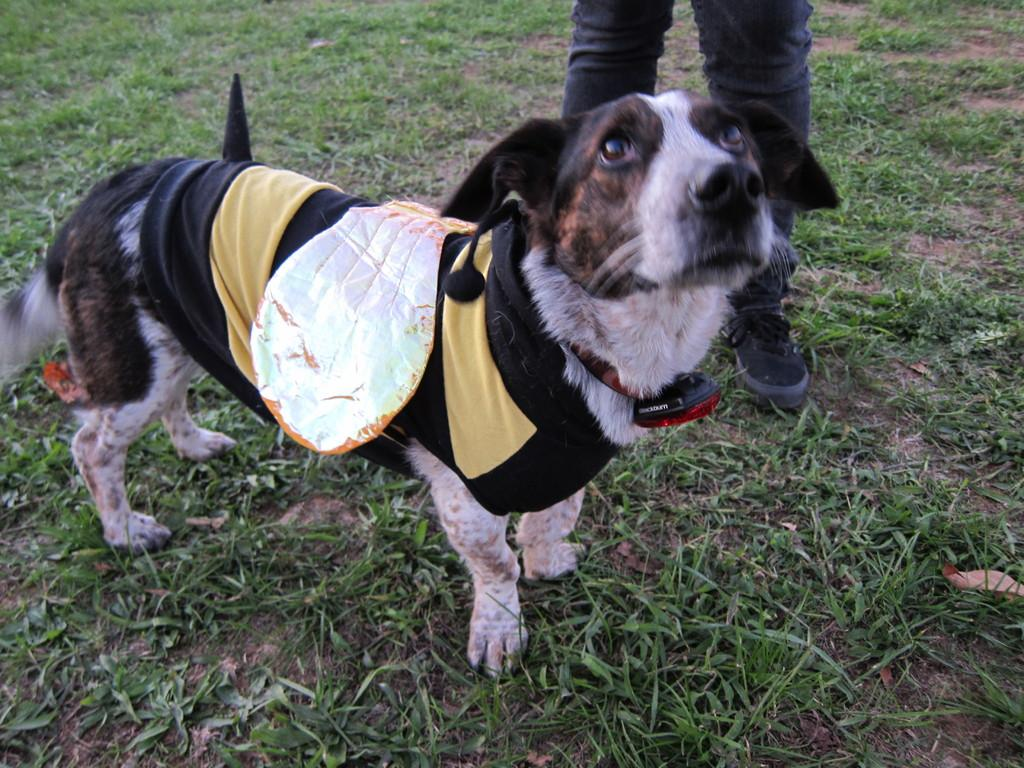What type of animal is in the image? There is a dog in the image. What is the dog doing in the image? The dog is standing on the ground. Is there a person in the image? Yes, there is a person in the image. How is the person positioned in relation to the dog? The person is standing behind the dog. What part of the person is visible in the image? Only the legs of the person are visible. What kind of apparatus is the dog using to perform tricks in the image? There is no apparatus present in the image, and the dog is not performing any tricks. How many visitors are present in the image? There is no mention of visitors in the image; only a dog and a person are present. 